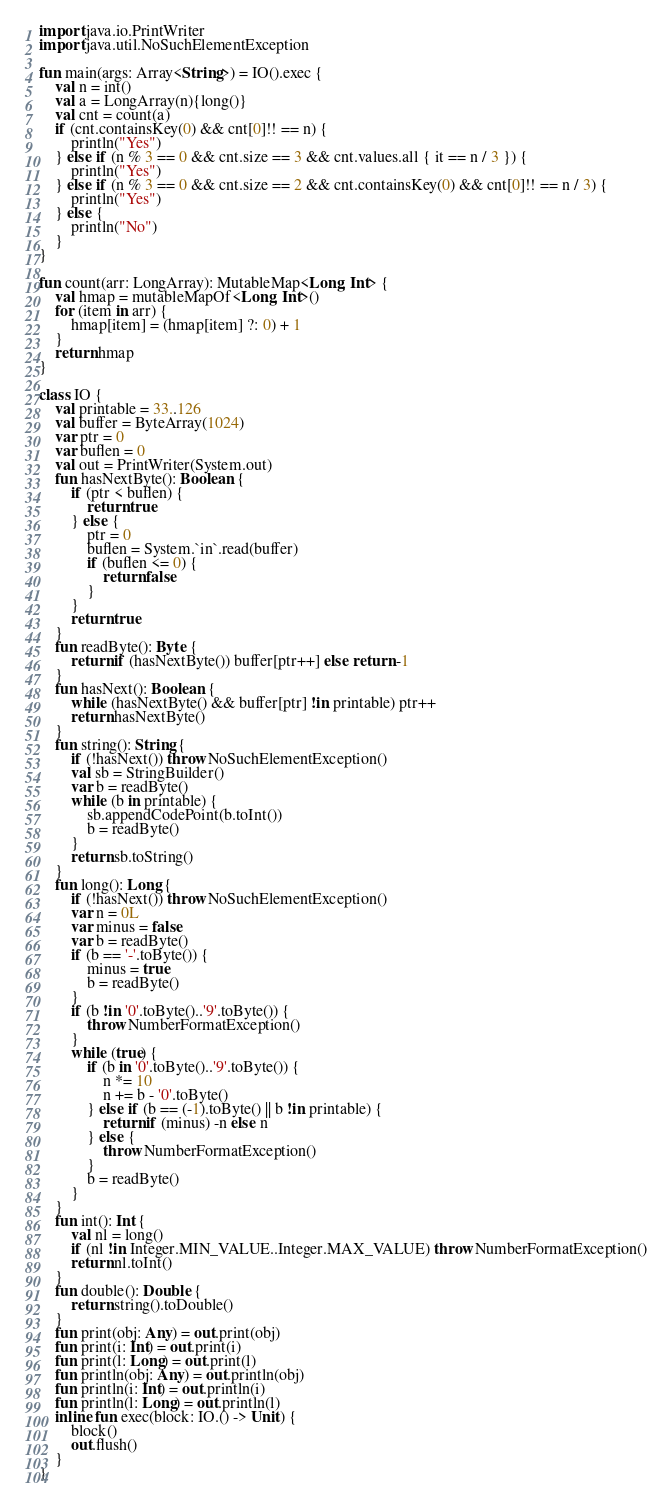Convert code to text. <code><loc_0><loc_0><loc_500><loc_500><_Kotlin_>import java.io.PrintWriter
import java.util.NoSuchElementException

fun main(args: Array<String>) = IO().exec {
    val n = int()
    val a = LongArray(n){long()}
    val cnt = count(a)
    if (cnt.containsKey(0) && cnt[0]!! == n) {
        println("Yes")
    } else if (n % 3 == 0 && cnt.size == 3 && cnt.values.all { it == n / 3 }) {
        println("Yes")
    } else if (n % 3 == 0 && cnt.size == 2 && cnt.containsKey(0) && cnt[0]!! == n / 3) {
        println("Yes")
    } else {
        println("No")
    }
}

fun count(arr: LongArray): MutableMap<Long, Int> {
    val hmap = mutableMapOf<Long, Int>()
    for (item in arr) {
        hmap[item] = (hmap[item] ?: 0) + 1
    }
    return hmap
}

class IO {
    val printable = 33..126
    val buffer = ByteArray(1024)
    var ptr = 0
    var buflen = 0
    val out = PrintWriter(System.out)
    fun hasNextByte(): Boolean {
        if (ptr < buflen) {
            return true
        } else {
            ptr = 0
            buflen = System.`in`.read(buffer)
            if (buflen <= 0) {
                return false
            }
        }
        return true
    }
    fun readByte(): Byte {
        return if (hasNextByte()) buffer[ptr++] else return -1
    }
    fun hasNext(): Boolean {
        while (hasNextByte() && buffer[ptr] !in printable) ptr++
        return hasNextByte()
    }
    fun string(): String {
        if (!hasNext()) throw NoSuchElementException()
        val sb = StringBuilder()
        var b = readByte()
        while (b in printable) {
            sb.appendCodePoint(b.toInt())
            b = readByte()
        }
        return sb.toString()
    }
    fun long(): Long {
        if (!hasNext()) throw NoSuchElementException()
        var n = 0L
        var minus = false
        var b = readByte()
        if (b == '-'.toByte()) {
            minus = true
            b = readByte()
        }
        if (b !in '0'.toByte()..'9'.toByte()) {
            throw NumberFormatException()
        }
        while (true) {
            if (b in '0'.toByte()..'9'.toByte()) {
                n *= 10
                n += b - '0'.toByte()
            } else if (b == (-1).toByte() || b !in printable) {
                return if (minus) -n else n
            } else {
                throw NumberFormatException()
            }
            b = readByte()
        }
    }
    fun int(): Int {
        val nl = long()
        if (nl !in Integer.MIN_VALUE..Integer.MAX_VALUE) throw NumberFormatException()
        return nl.toInt()
    }
    fun double(): Double {
        return string().toDouble()
    }
    fun print(obj: Any) = out.print(obj)
    fun print(i: Int) = out.print(i)
    fun print(l: Long) = out.print(l)
    fun println(obj: Any) = out.println(obj)
    fun println(i: Int) = out.println(i)
    fun println(l: Long) = out.println(l)
    inline fun exec(block: IO.() -> Unit) {
        block()
        out.flush()
    }
}</code> 